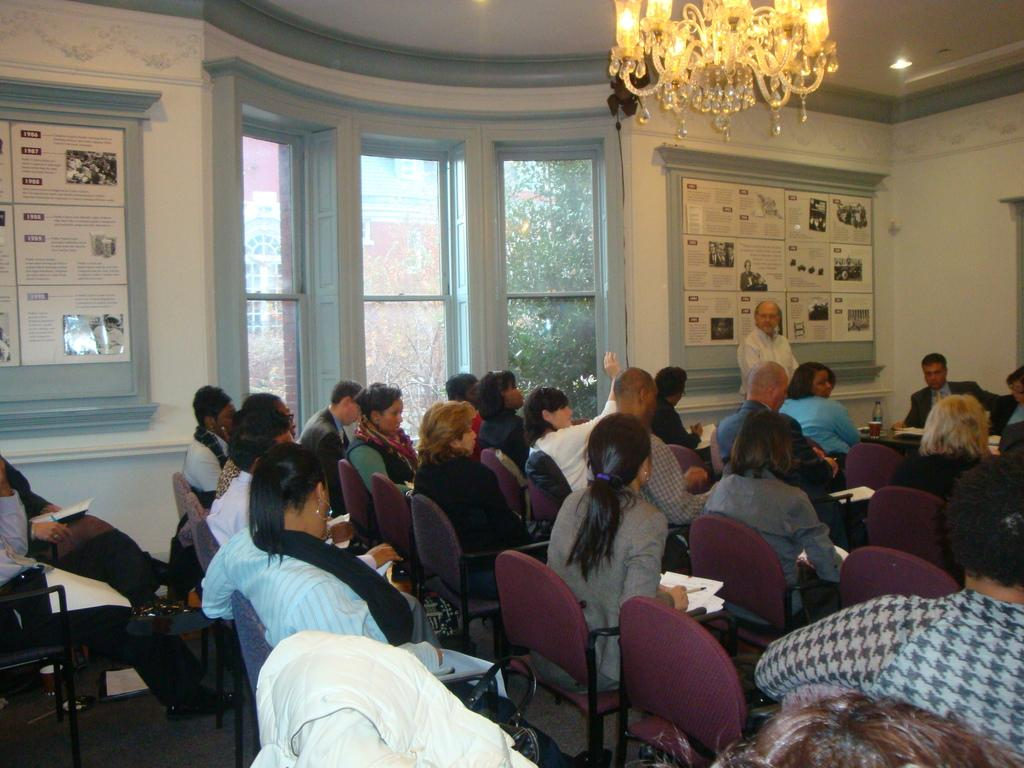What are the people in the image doing? There are many people sitting on chairs in the image. What can be seen behind the people? There is a glass window in the image. What is present on the wall in the image? There is a board in the image. What type of lighting fixture is visible in the image? There is a chandelier fixed to the ceiling in the image. What type of steam can be seen coming from the chandelier in the image? There is no steam coming from the chandelier in the image. Is there a cemetery visible in the image? No, there is no cemetery present in the image. 